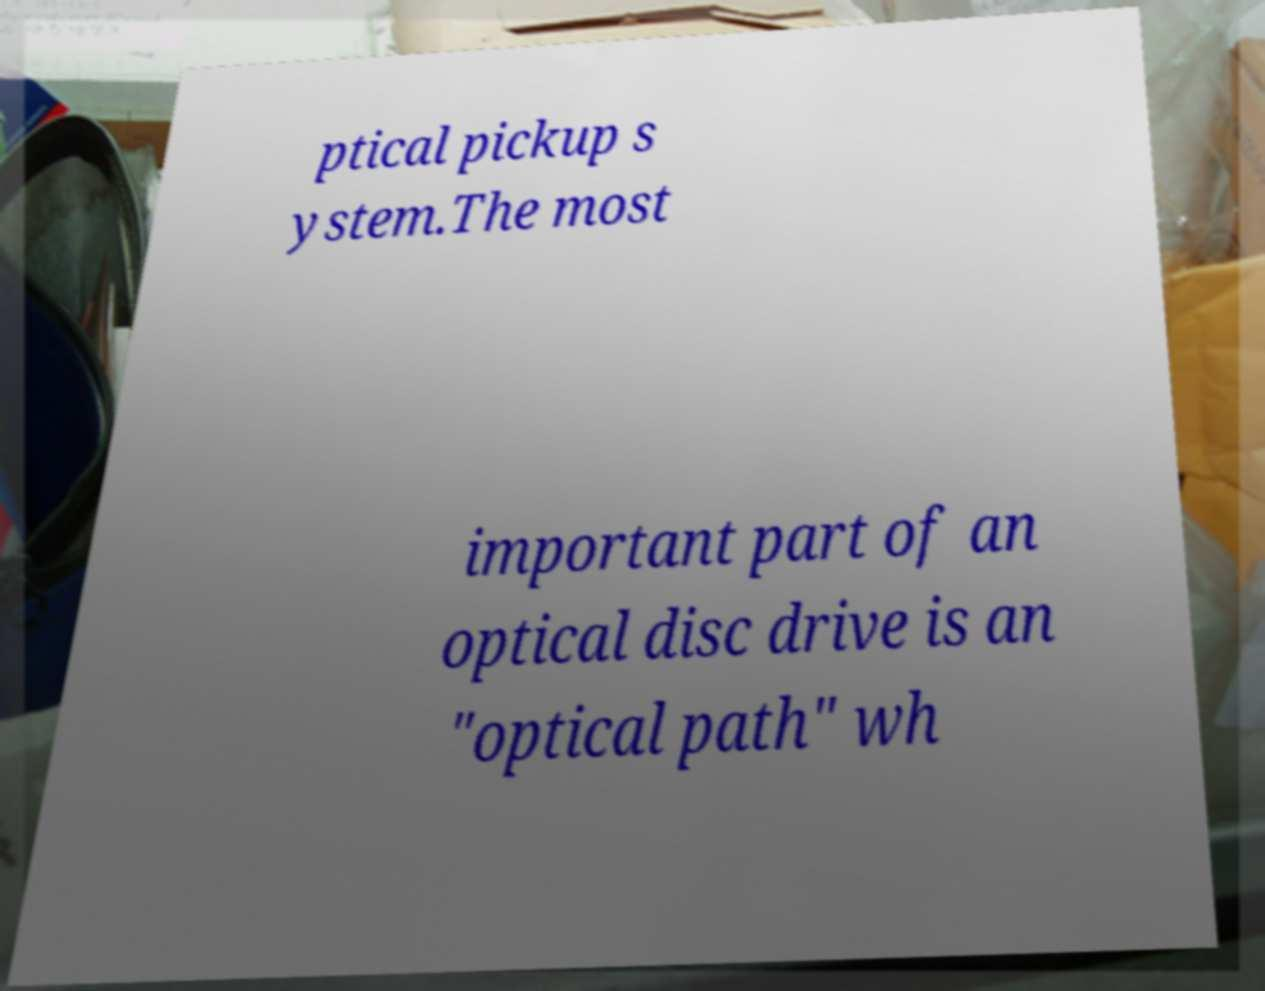Could you assist in decoding the text presented in this image and type it out clearly? ptical pickup s ystem.The most important part of an optical disc drive is an "optical path" wh 